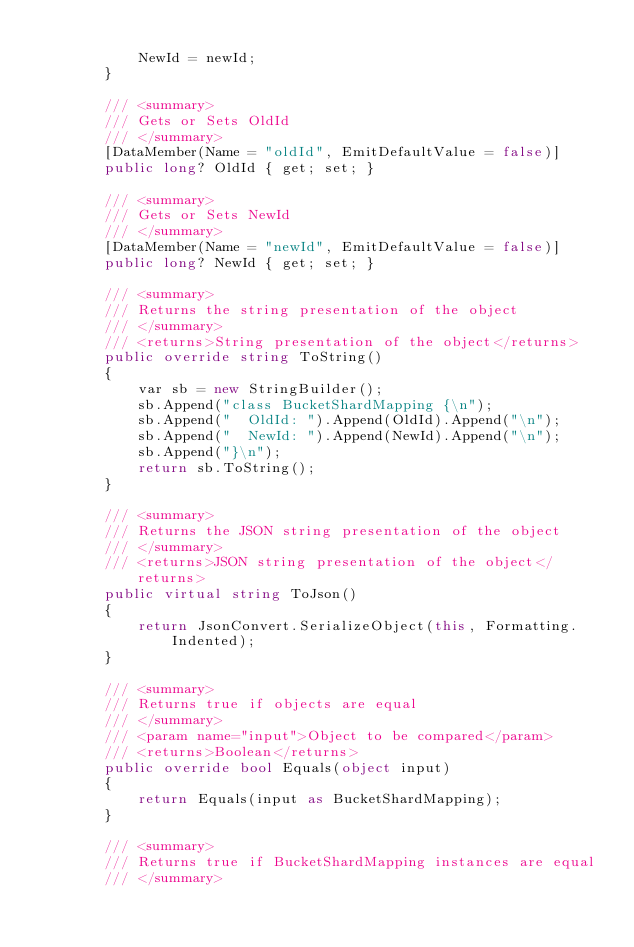<code> <loc_0><loc_0><loc_500><loc_500><_C#_>
            NewId = newId;
        }

        /// <summary>
        /// Gets or Sets OldId
        /// </summary>
        [DataMember(Name = "oldId", EmitDefaultValue = false)]
        public long? OldId { get; set; }

        /// <summary>
        /// Gets or Sets NewId
        /// </summary>
        [DataMember(Name = "newId", EmitDefaultValue = false)]
        public long? NewId { get; set; }

        /// <summary>
        /// Returns the string presentation of the object
        /// </summary>
        /// <returns>String presentation of the object</returns>
        public override string ToString()
        {
            var sb = new StringBuilder();
            sb.Append("class BucketShardMapping {\n");
            sb.Append("  OldId: ").Append(OldId).Append("\n");
            sb.Append("  NewId: ").Append(NewId).Append("\n");
            sb.Append("}\n");
            return sb.ToString();
        }

        /// <summary>
        /// Returns the JSON string presentation of the object
        /// </summary>
        /// <returns>JSON string presentation of the object</returns>
        public virtual string ToJson()
        {
            return JsonConvert.SerializeObject(this, Formatting.Indented);
        }

        /// <summary>
        /// Returns true if objects are equal
        /// </summary>
        /// <param name="input">Object to be compared</param>
        /// <returns>Boolean</returns>
        public override bool Equals(object input)
        {
            return Equals(input as BucketShardMapping);
        }

        /// <summary>
        /// Returns true if BucketShardMapping instances are equal
        /// </summary></code> 